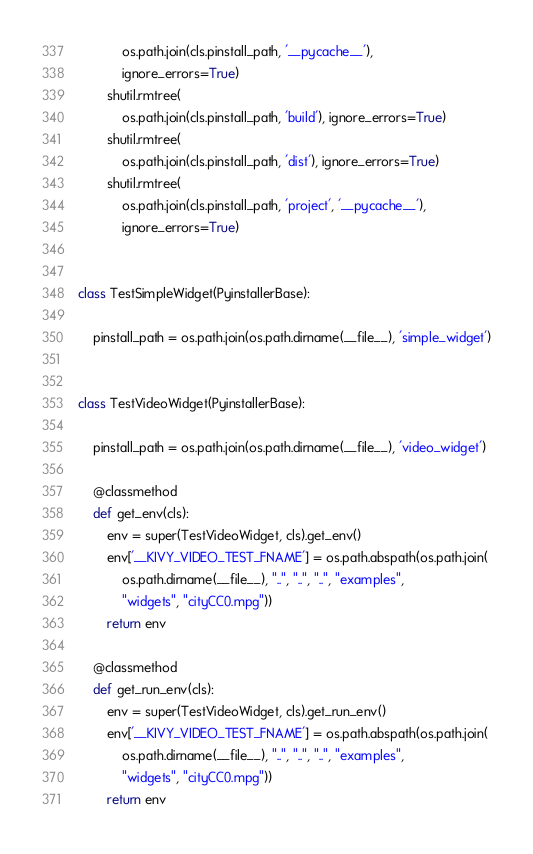Convert code to text. <code><loc_0><loc_0><loc_500><loc_500><_Python_>            os.path.join(cls.pinstall_path, '__pycache__'),
            ignore_errors=True)
        shutil.rmtree(
            os.path.join(cls.pinstall_path, 'build'), ignore_errors=True)
        shutil.rmtree(
            os.path.join(cls.pinstall_path, 'dist'), ignore_errors=True)
        shutil.rmtree(
            os.path.join(cls.pinstall_path, 'project', '__pycache__'),
            ignore_errors=True)


class TestSimpleWidget(PyinstallerBase):

    pinstall_path = os.path.join(os.path.dirname(__file__), 'simple_widget')


class TestVideoWidget(PyinstallerBase):

    pinstall_path = os.path.join(os.path.dirname(__file__), 'video_widget')

    @classmethod
    def get_env(cls):
        env = super(TestVideoWidget, cls).get_env()
        env['__KIVY_VIDEO_TEST_FNAME'] = os.path.abspath(os.path.join(
            os.path.dirname(__file__), "..", "..", "..", "examples",
            "widgets", "cityCC0.mpg"))
        return env

    @classmethod
    def get_run_env(cls):
        env = super(TestVideoWidget, cls).get_run_env()
        env['__KIVY_VIDEO_TEST_FNAME'] = os.path.abspath(os.path.join(
            os.path.dirname(__file__), "..", "..", "..", "examples",
            "widgets", "cityCC0.mpg"))
        return env
</code> 